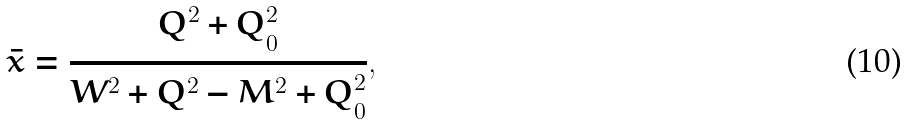<formula> <loc_0><loc_0><loc_500><loc_500>\bar { x } = \frac { Q ^ { 2 } + Q ^ { 2 } _ { 0 } } { W ^ { 2 } + Q ^ { 2 } - M ^ { 2 } + Q ^ { 2 } _ { 0 } } ,</formula> 